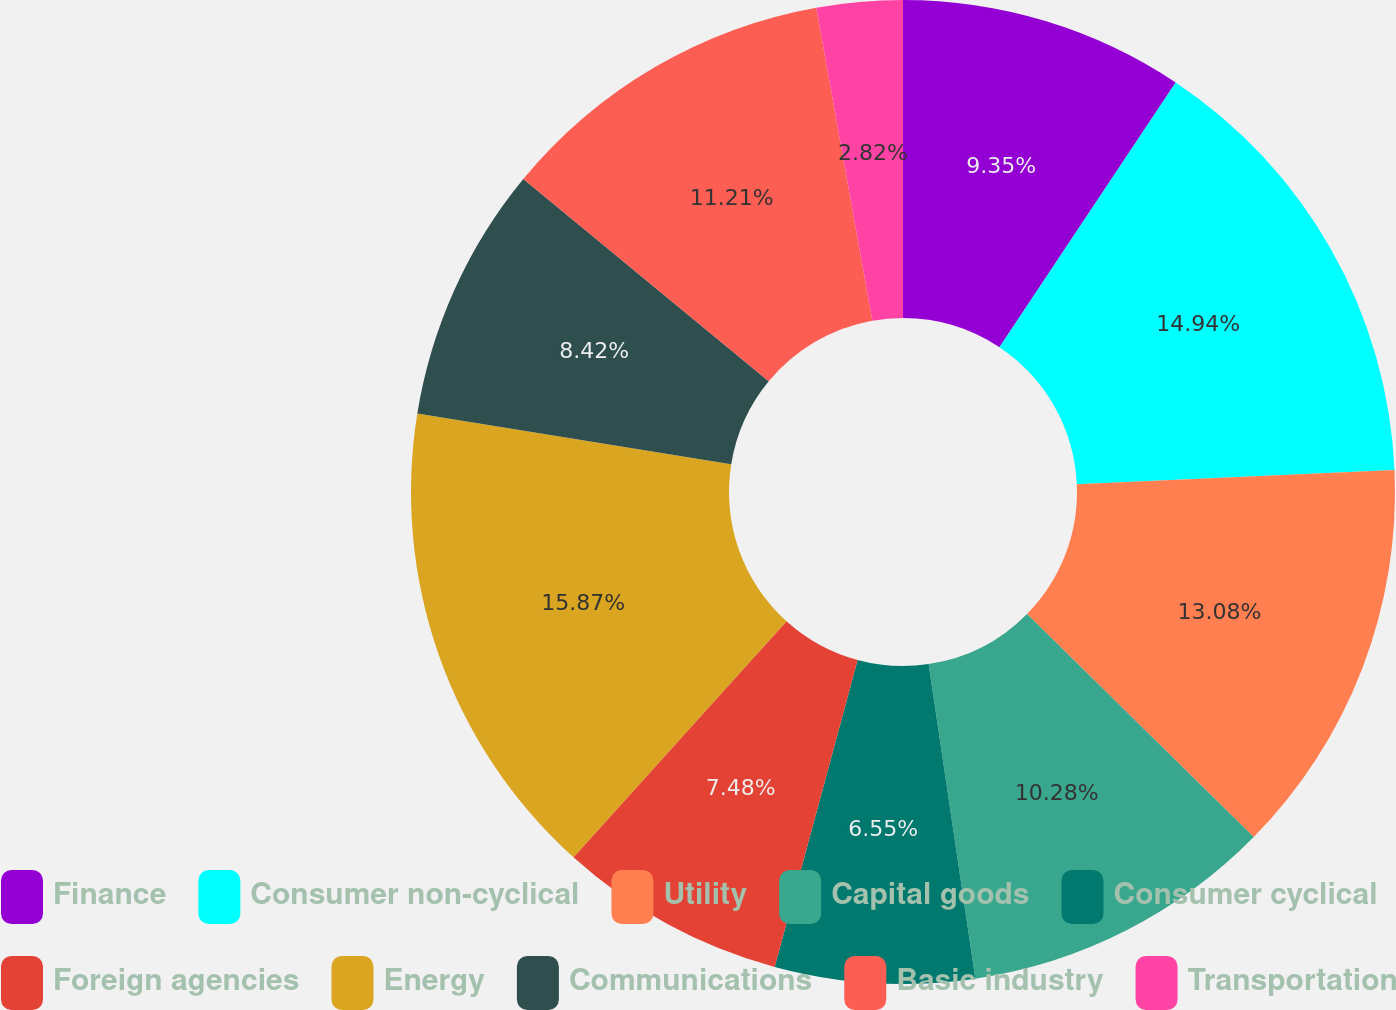Convert chart. <chart><loc_0><loc_0><loc_500><loc_500><pie_chart><fcel>Finance<fcel>Consumer non-cyclical<fcel>Utility<fcel>Capital goods<fcel>Consumer cyclical<fcel>Foreign agencies<fcel>Energy<fcel>Communications<fcel>Basic industry<fcel>Transportation<nl><fcel>9.35%<fcel>14.94%<fcel>13.08%<fcel>10.28%<fcel>6.55%<fcel>7.48%<fcel>15.87%<fcel>8.42%<fcel>11.21%<fcel>2.82%<nl></chart> 